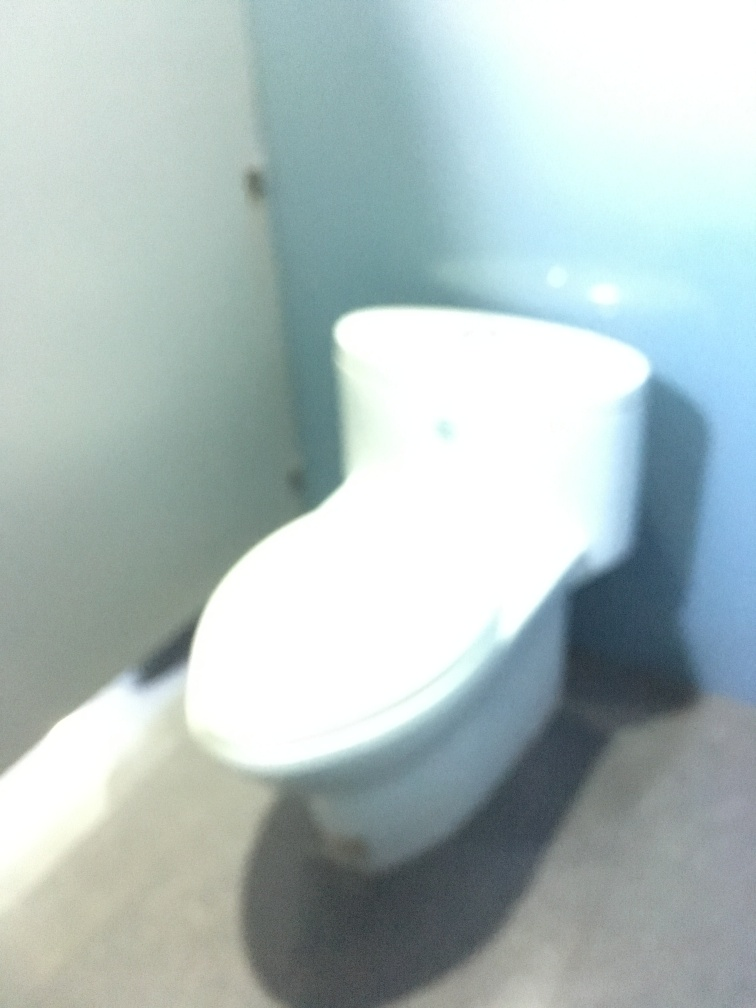What factors might have caused the quality of this photo to be poor? Several factors could have led to the poor quality of this photo. It seems that there was camera shake during the shot, possibly due to the photographer holding the camera unsteadily. Inadequate lighting conditions and incorrect focus settings could also contribute. Finally, the photographer might have been too close to the subject without the appropriate macro settings or lens. 